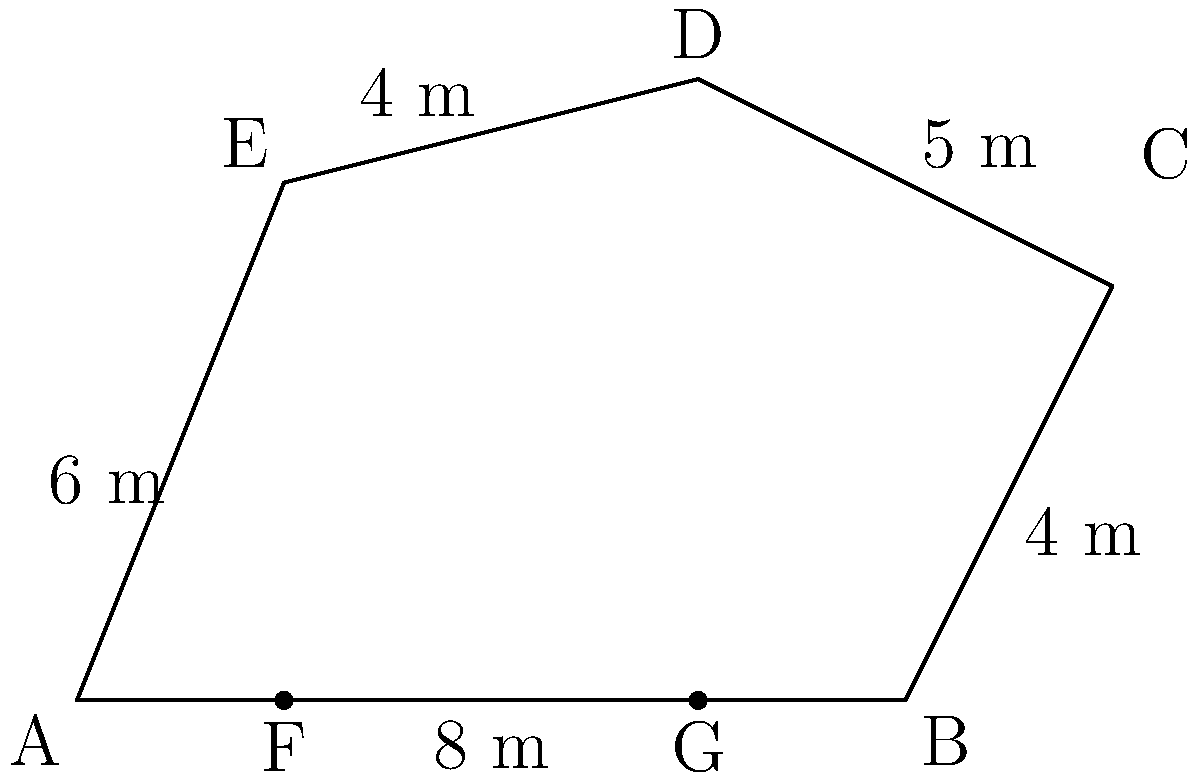During an excavation of an ancient African settlement, you uncover the foundation of an irregular pentagonal structure. The floor plan is shown in the diagram above. Calculate the area of this structure in square meters. To find the area of this irregular pentagon, we can divide it into simpler shapes and sum their areas. Let's break it down step by step:

1) First, divide the pentagon into a rectangle (ABGF) and two triangles (FCG and DEG).

2) Calculate the area of rectangle ABGF:
   Length = 6 m, Width = 2 m
   Area of ABGF = $6 \times 2 = 12$ m²

3) Calculate the area of triangle FCG:
   Base = 4 m, Height = 4 m
   Area of FCG = $\frac{1}{2} \times 4 \times 4 = 8$ m²

4) Calculate the area of triangle DEG:
   Base = 4 m, Height = 6 m
   Area of DEG = $\frac{1}{2} \times 4 \times 6 = 12$ m²

5) Sum up all the areas:
   Total Area = Area of ABGF + Area of FCG + Area of DEG
               = $12 + 8 + 12 = 32$ m²

Therefore, the total area of the excavated structure is 32 square meters.
Answer: 32 m² 